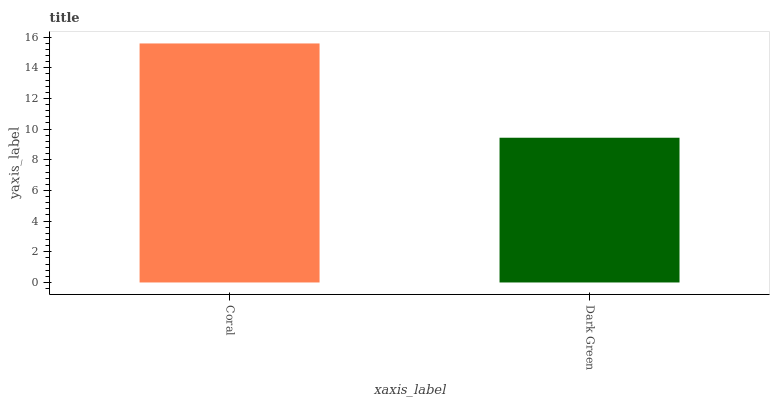Is Dark Green the minimum?
Answer yes or no. Yes. Is Coral the maximum?
Answer yes or no. Yes. Is Dark Green the maximum?
Answer yes or no. No. Is Coral greater than Dark Green?
Answer yes or no. Yes. Is Dark Green less than Coral?
Answer yes or no. Yes. Is Dark Green greater than Coral?
Answer yes or no. No. Is Coral less than Dark Green?
Answer yes or no. No. Is Coral the high median?
Answer yes or no. Yes. Is Dark Green the low median?
Answer yes or no. Yes. Is Dark Green the high median?
Answer yes or no. No. Is Coral the low median?
Answer yes or no. No. 